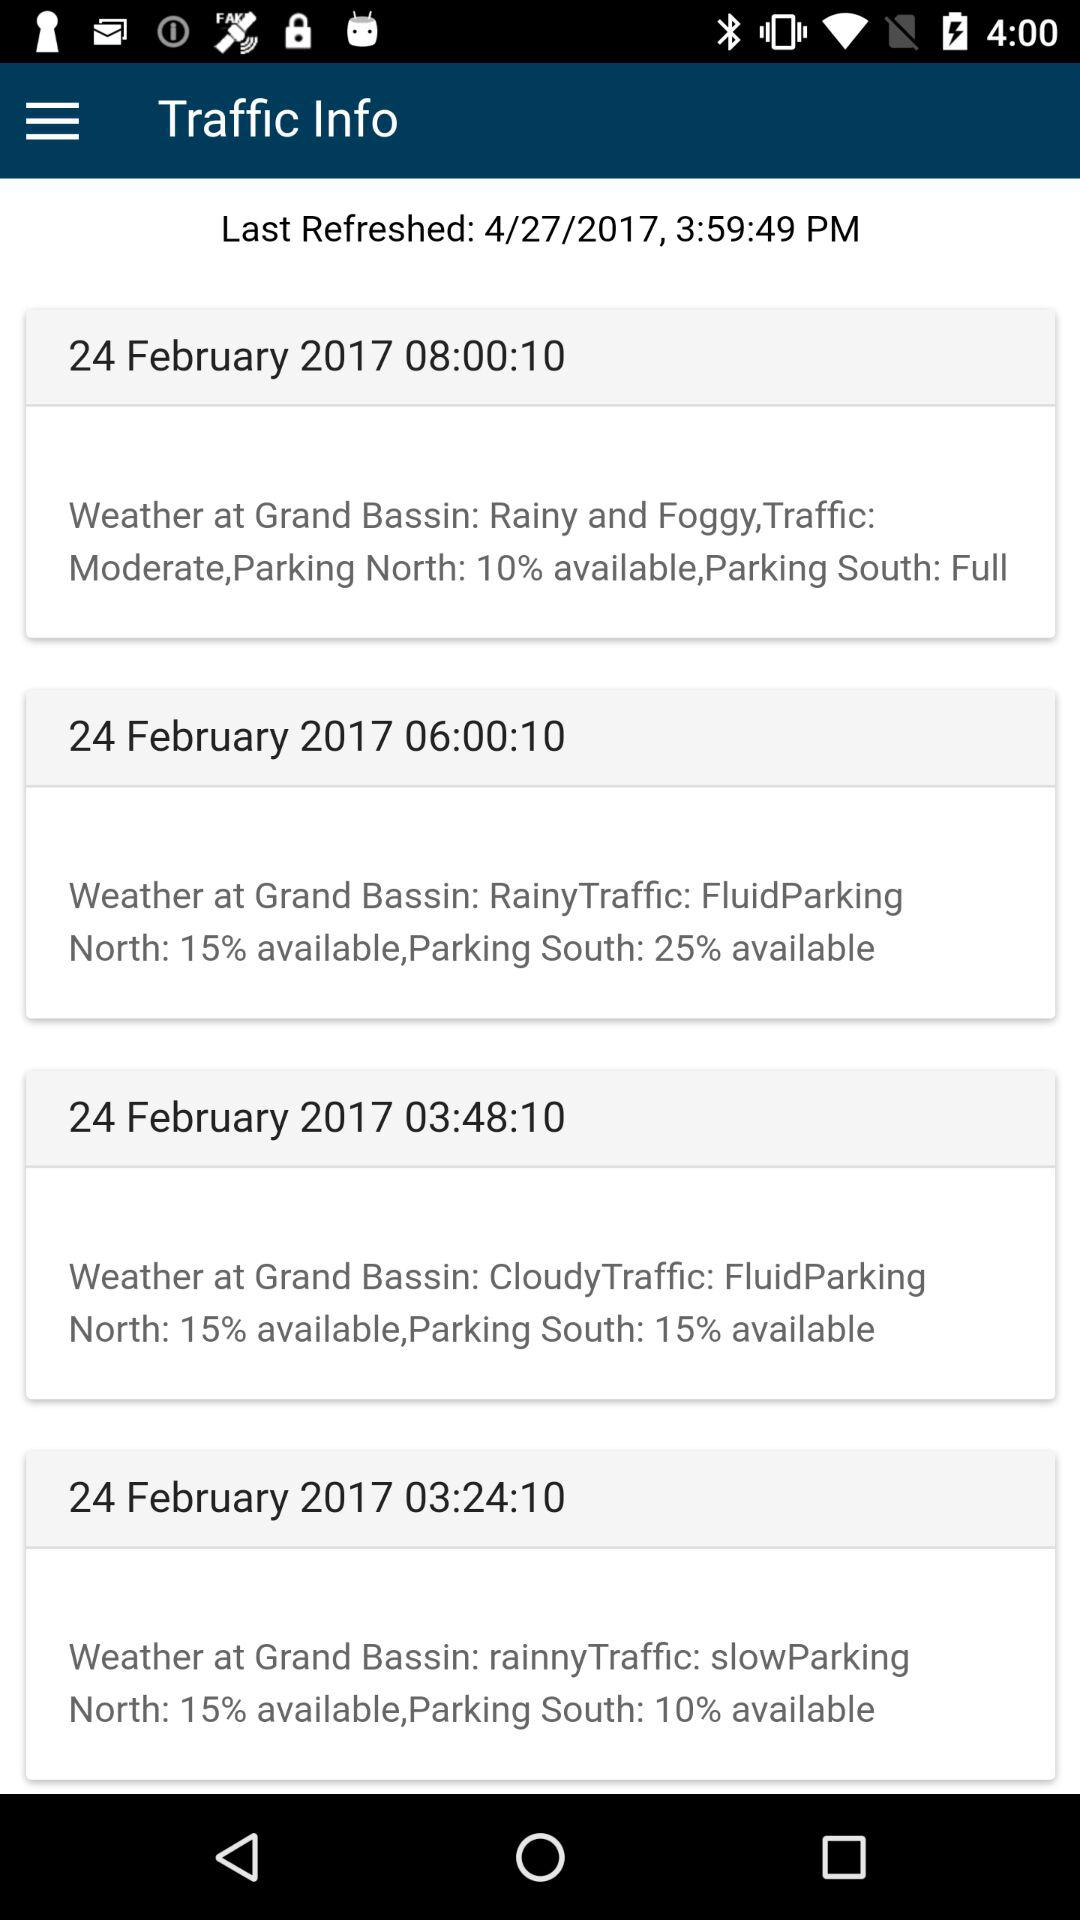When did the last refresh happen? The last refresh happened on April 27, 2017 at 3:59:49 PM. 